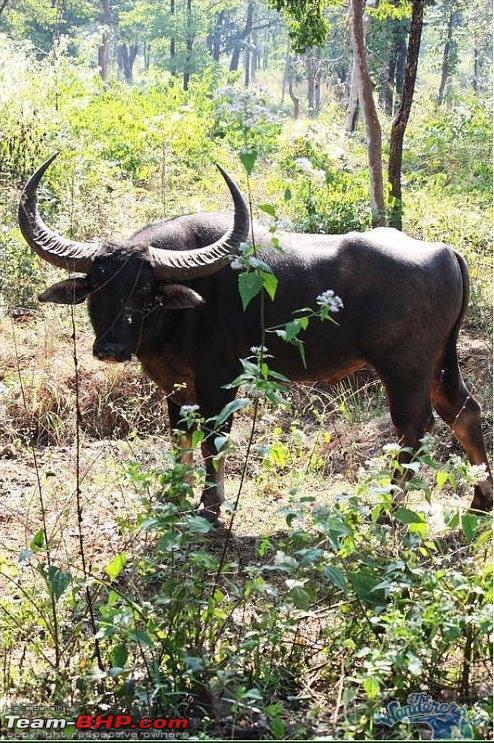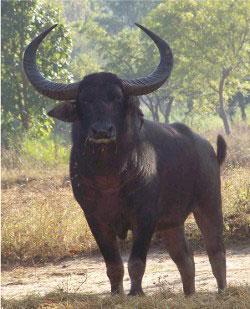The first image is the image on the left, the second image is the image on the right. For the images shown, is this caption "There are two adult horned buffalo and no water." true? Answer yes or no. Yes. The first image is the image on the left, the second image is the image on the right. For the images shown, is this caption "In the image to the left, the ox is standing, surrounded by GREEN vegetation/grass." true? Answer yes or no. Yes. 